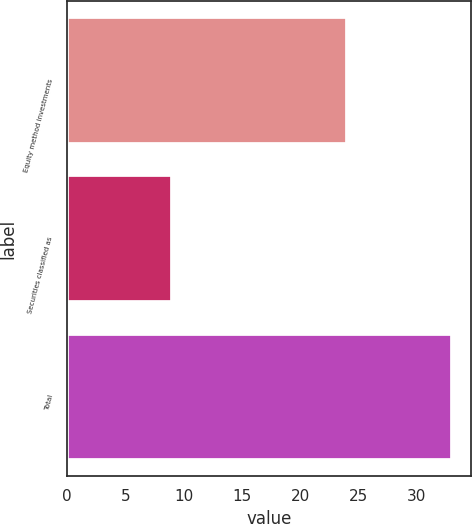Convert chart to OTSL. <chart><loc_0><loc_0><loc_500><loc_500><bar_chart><fcel>Equity method investments<fcel>Securities classified as<fcel>Total<nl><fcel>24<fcel>9<fcel>33<nl></chart> 